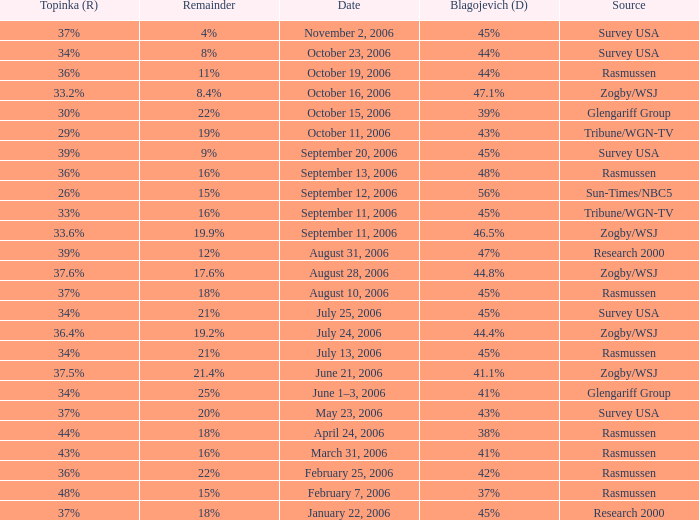Which Blagojevich (D) happened on october 16, 2006? 47.1%. I'm looking to parse the entire table for insights. Could you assist me with that? {'header': ['Topinka (R)', 'Remainder', 'Date', 'Blagojevich (D)', 'Source'], 'rows': [['37%', '4%', 'November 2, 2006', '45%', 'Survey USA'], ['34%', '8%', 'October 23, 2006', '44%', 'Survey USA'], ['36%', '11%', 'October 19, 2006', '44%', 'Rasmussen'], ['33.2%', '8.4%', 'October 16, 2006', '47.1%', 'Zogby/WSJ'], ['30%', '22%', 'October 15, 2006', '39%', 'Glengariff Group'], ['29%', '19%', 'October 11, 2006', '43%', 'Tribune/WGN-TV'], ['39%', '9%', 'September 20, 2006', '45%', 'Survey USA'], ['36%', '16%', 'September 13, 2006', '48%', 'Rasmussen'], ['26%', '15%', 'September 12, 2006', '56%', 'Sun-Times/NBC5'], ['33%', '16%', 'September 11, 2006', '45%', 'Tribune/WGN-TV'], ['33.6%', '19.9%', 'September 11, 2006', '46.5%', 'Zogby/WSJ'], ['39%', '12%', 'August 31, 2006', '47%', 'Research 2000'], ['37.6%', '17.6%', 'August 28, 2006', '44.8%', 'Zogby/WSJ'], ['37%', '18%', 'August 10, 2006', '45%', 'Rasmussen'], ['34%', '21%', 'July 25, 2006', '45%', 'Survey USA'], ['36.4%', '19.2%', 'July 24, 2006', '44.4%', 'Zogby/WSJ'], ['34%', '21%', 'July 13, 2006', '45%', 'Rasmussen'], ['37.5%', '21.4%', 'June 21, 2006', '41.1%', 'Zogby/WSJ'], ['34%', '25%', 'June 1–3, 2006', '41%', 'Glengariff Group'], ['37%', '20%', 'May 23, 2006', '43%', 'Survey USA'], ['44%', '18%', 'April 24, 2006', '38%', 'Rasmussen'], ['43%', '16%', 'March 31, 2006', '41%', 'Rasmussen'], ['36%', '22%', 'February 25, 2006', '42%', 'Rasmussen'], ['48%', '15%', 'February 7, 2006', '37%', 'Rasmussen'], ['37%', '18%', 'January 22, 2006', '45%', 'Research 2000']]} 